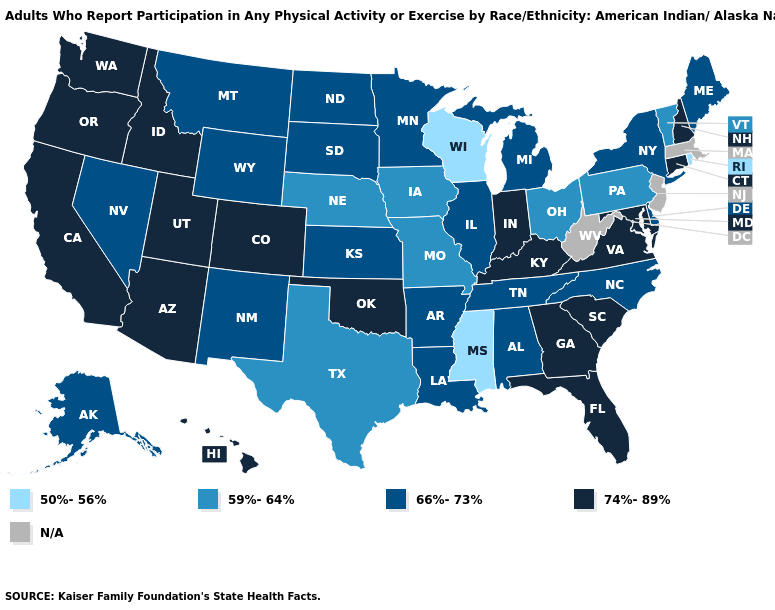What is the highest value in the South ?
Give a very brief answer. 74%-89%. Name the states that have a value in the range 50%-56%?
Quick response, please. Mississippi, Rhode Island, Wisconsin. Name the states that have a value in the range 50%-56%?
Answer briefly. Mississippi, Rhode Island, Wisconsin. What is the highest value in the Northeast ?
Write a very short answer. 74%-89%. What is the value of North Carolina?
Write a very short answer. 66%-73%. What is the value of South Carolina?
Give a very brief answer. 74%-89%. Name the states that have a value in the range 59%-64%?
Short answer required. Iowa, Missouri, Nebraska, Ohio, Pennsylvania, Texas, Vermont. Does the first symbol in the legend represent the smallest category?
Keep it brief. Yes. Which states have the highest value in the USA?
Write a very short answer. Arizona, California, Colorado, Connecticut, Florida, Georgia, Hawaii, Idaho, Indiana, Kentucky, Maryland, New Hampshire, Oklahoma, Oregon, South Carolina, Utah, Virginia, Washington. What is the value of Nebraska?
Short answer required. 59%-64%. Does the first symbol in the legend represent the smallest category?
Answer briefly. Yes. What is the highest value in the USA?
Answer briefly. 74%-89%. Name the states that have a value in the range 66%-73%?
Quick response, please. Alabama, Alaska, Arkansas, Delaware, Illinois, Kansas, Louisiana, Maine, Michigan, Minnesota, Montana, Nevada, New Mexico, New York, North Carolina, North Dakota, South Dakota, Tennessee, Wyoming. What is the value of Mississippi?
Give a very brief answer. 50%-56%. 